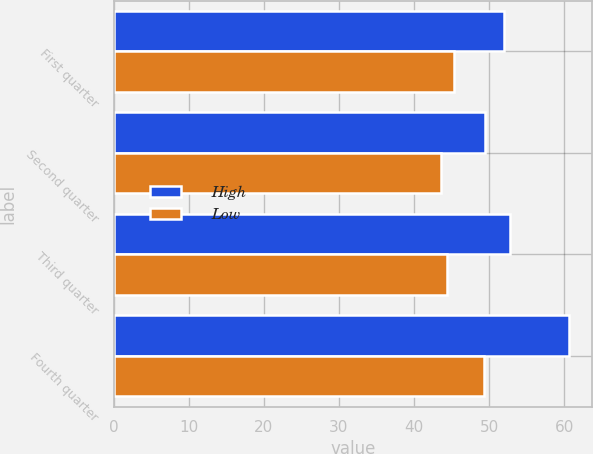Convert chart. <chart><loc_0><loc_0><loc_500><loc_500><stacked_bar_chart><ecel><fcel>First quarter<fcel>Second quarter<fcel>Third quarter<fcel>Fourth quarter<nl><fcel>High<fcel>51.94<fcel>49.49<fcel>52.78<fcel>60.64<nl><fcel>Low<fcel>45.35<fcel>43.56<fcel>44.34<fcel>49.29<nl></chart> 